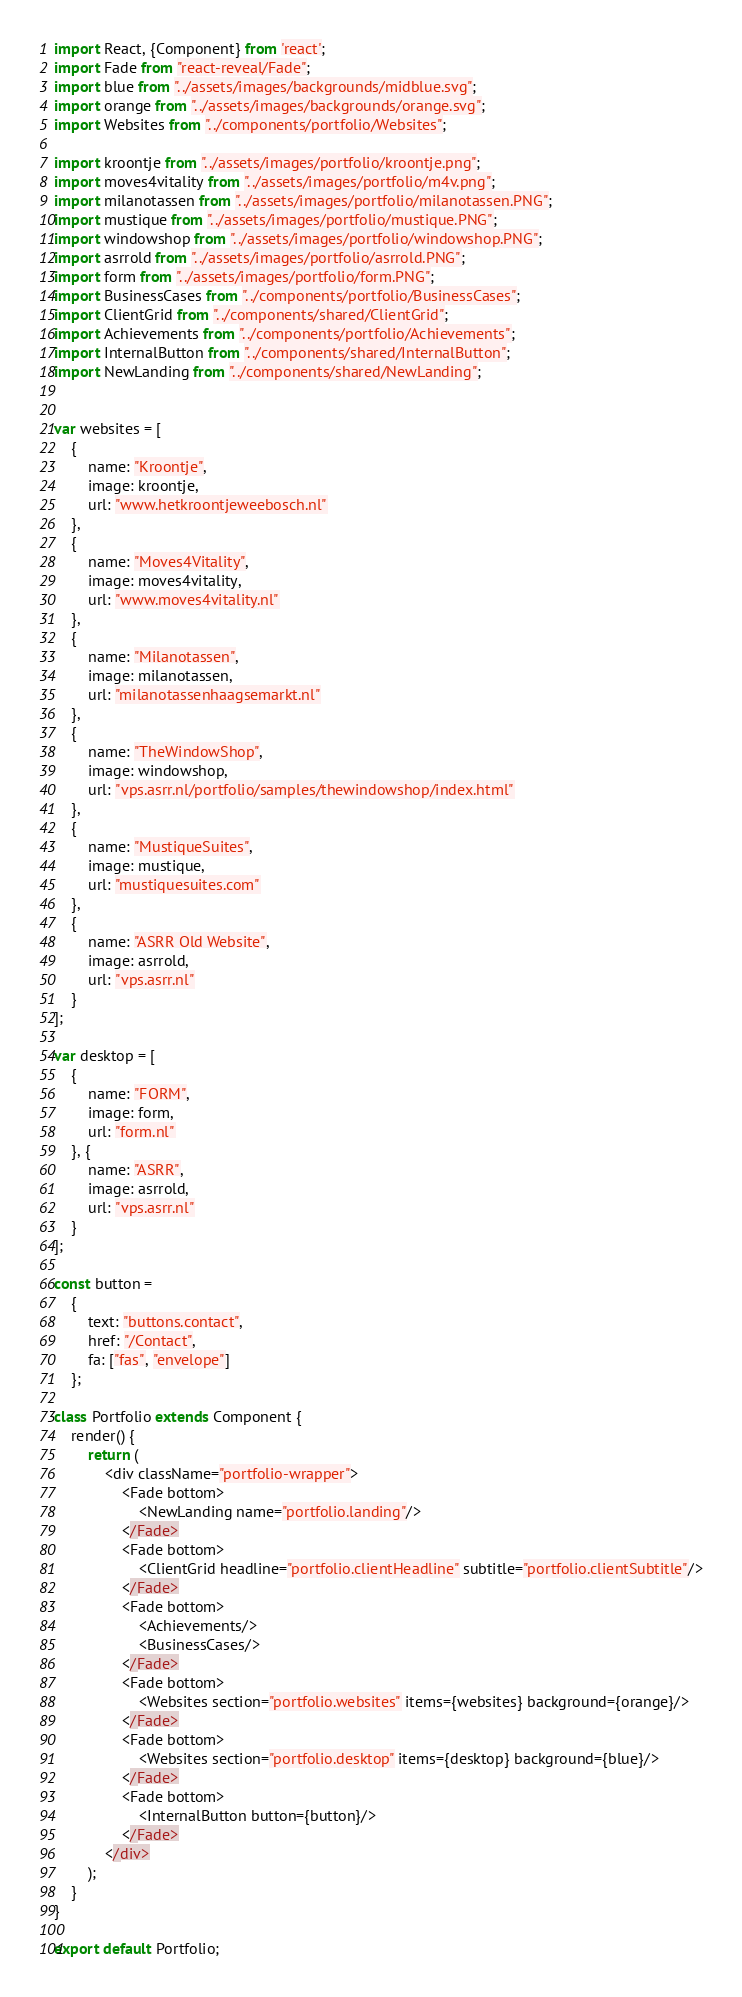Convert code to text. <code><loc_0><loc_0><loc_500><loc_500><_JavaScript_>import React, {Component} from 'react';
import Fade from "react-reveal/Fade";
import blue from "../assets/images/backgrounds/midblue.svg";
import orange from "../assets/images/backgrounds/orange.svg";
import Websites from "../components/portfolio/Websites";

import kroontje from "../assets/images/portfolio/kroontje.png";
import moves4vitality from "../assets/images/portfolio/m4v.png";
import milanotassen from "../assets/images/portfolio/milanotassen.PNG";
import mustique from "../assets/images/portfolio/mustique.PNG";
import windowshop from "../assets/images/portfolio/windowshop.PNG";
import asrrold from "../assets/images/portfolio/asrrold.PNG";
import form from "../assets/images/portfolio/form.PNG";
import BusinessCases from "../components/portfolio/BusinessCases";
import ClientGrid from "../components/shared/ClientGrid";
import Achievements from "../components/portfolio/Achievements";
import InternalButton from "../components/shared/InternalButton";
import NewLanding from "../components/shared/NewLanding";


var websites = [
	{
		name: "Kroontje",
		image: kroontje,
		url: "www.hetkroontjeweebosch.nl"
	},
	{
		name: "Moves4Vitality",
		image: moves4vitality,
		url: "www.moves4vitality.nl"
	},
	{
		name: "Milanotassen",
		image: milanotassen,
		url: "milanotassenhaagsemarkt.nl"
	},
	{
		name: "TheWindowShop",
		image: windowshop,
		url: "vps.asrr.nl/portfolio/samples/thewindowshop/index.html"
	},
	{
		name: "MustiqueSuites",
		image: mustique,
		url: "mustiquesuites.com"
	},
	{
		name: "ASRR Old Website",
		image: asrrold,
		url: "vps.asrr.nl"
	}
];

var desktop = [
	{
		name: "FORM",
		image: form,
		url: "form.nl"
	}, {
		name: "ASRR",
		image: asrrold,
		url: "vps.asrr.nl"
	}
];

const button =
	{
		text: "buttons.contact",
		href: "/Contact",
		fa: ["fas", "envelope"]
	};

class Portfolio extends Component {
	render() {
		return (
			<div className="portfolio-wrapper">
				<Fade bottom>
					<NewLanding name="portfolio.landing"/>
				</Fade>
				<Fade bottom>
					<ClientGrid headline="portfolio.clientHeadline" subtitle="portfolio.clientSubtitle"/>
				</Fade>
				<Fade bottom>
					<Achievements/>
					<BusinessCases/>
				</Fade>
				<Fade bottom>
					<Websites section="portfolio.websites" items={websites} background={orange}/>
				</Fade>
				<Fade bottom>
					<Websites section="portfolio.desktop" items={desktop} background={blue}/>
				</Fade>
				<Fade bottom>
					<InternalButton button={button}/>
				</Fade>
			</div>
		);
	}
}

export default Portfolio;</code> 